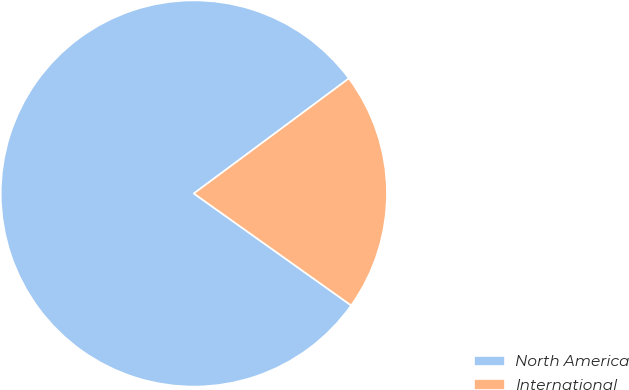Convert chart to OTSL. <chart><loc_0><loc_0><loc_500><loc_500><pie_chart><fcel>North America<fcel>International<nl><fcel>80.0%<fcel>20.0%<nl></chart> 